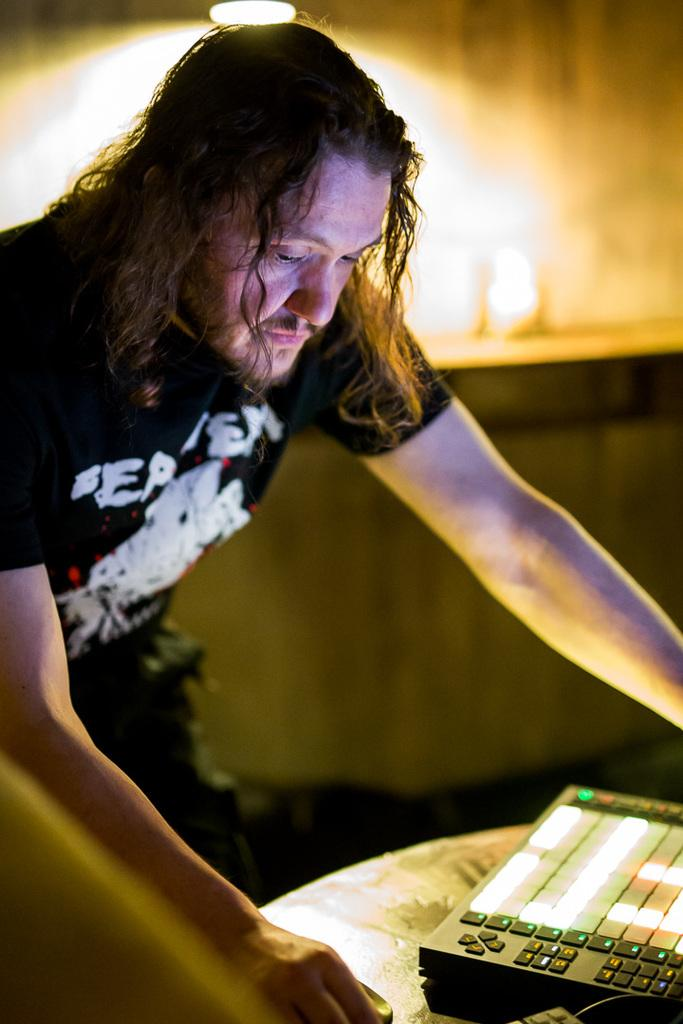What is the main subject of the image? There is a man standing in the image. What is in front of the man? There are objects on a table in front of the man. Can you describe the background of the image? The background of the image is blurry. What can be seen in terms of lighting in the image? There is light visible in the image. What type of hat is the man wearing in the image? The man is not wearing a hat in the image. What amusement park ride can be seen in the background of the image? There is no amusement park ride present in the image; the background is blurry. 